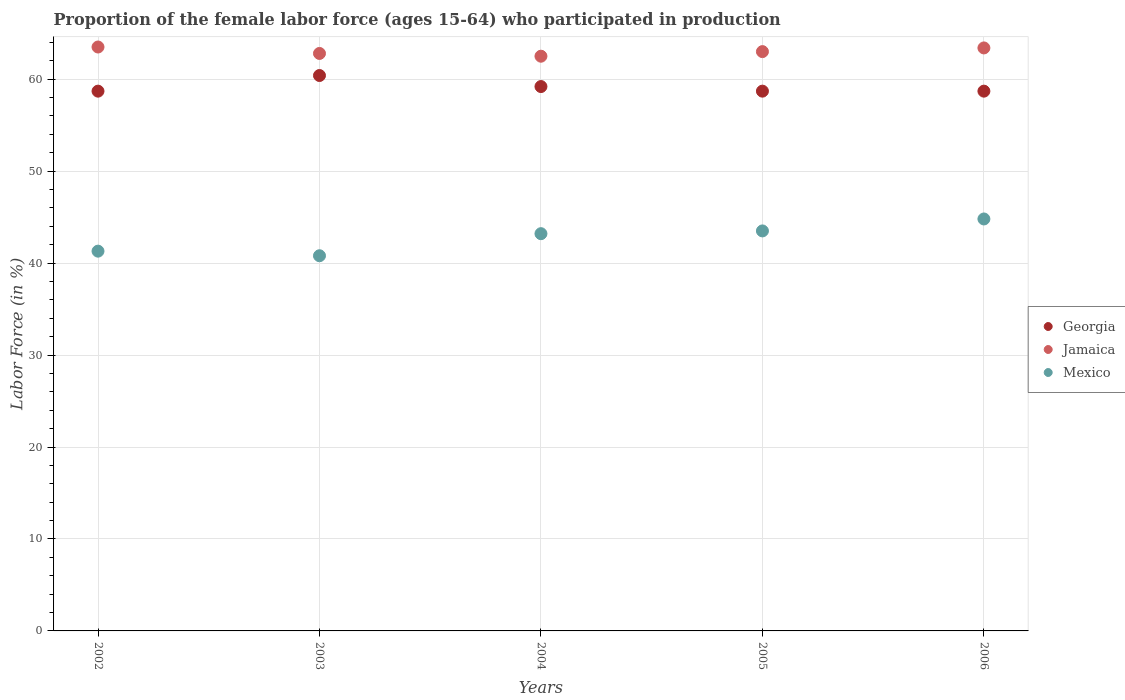What is the proportion of the female labor force who participated in production in Georgia in 2002?
Your response must be concise. 58.7. Across all years, what is the maximum proportion of the female labor force who participated in production in Jamaica?
Your response must be concise. 63.5. Across all years, what is the minimum proportion of the female labor force who participated in production in Georgia?
Make the answer very short. 58.7. In which year was the proportion of the female labor force who participated in production in Mexico maximum?
Make the answer very short. 2006. In which year was the proportion of the female labor force who participated in production in Jamaica minimum?
Offer a terse response. 2004. What is the total proportion of the female labor force who participated in production in Georgia in the graph?
Provide a succinct answer. 295.7. What is the difference between the proportion of the female labor force who participated in production in Mexico in 2003 and that in 2004?
Offer a very short reply. -2.4. What is the difference between the proportion of the female labor force who participated in production in Mexico in 2004 and the proportion of the female labor force who participated in production in Jamaica in 2002?
Provide a succinct answer. -20.3. What is the average proportion of the female labor force who participated in production in Mexico per year?
Make the answer very short. 42.72. In the year 2005, what is the difference between the proportion of the female labor force who participated in production in Georgia and proportion of the female labor force who participated in production in Jamaica?
Your response must be concise. -4.3. In how many years, is the proportion of the female labor force who participated in production in Jamaica greater than 54 %?
Provide a succinct answer. 5. What is the ratio of the proportion of the female labor force who participated in production in Mexico in 2003 to that in 2005?
Keep it short and to the point. 0.94. Is the proportion of the female labor force who participated in production in Georgia in 2004 less than that in 2006?
Offer a very short reply. No. Is the difference between the proportion of the female labor force who participated in production in Georgia in 2005 and 2006 greater than the difference between the proportion of the female labor force who participated in production in Jamaica in 2005 and 2006?
Keep it short and to the point. Yes. What is the difference between the highest and the second highest proportion of the female labor force who participated in production in Georgia?
Provide a succinct answer. 1.2. What is the difference between the highest and the lowest proportion of the female labor force who participated in production in Georgia?
Make the answer very short. 1.7. Does the proportion of the female labor force who participated in production in Georgia monotonically increase over the years?
Provide a short and direct response. No. Is the proportion of the female labor force who participated in production in Mexico strictly greater than the proportion of the female labor force who participated in production in Jamaica over the years?
Offer a very short reply. No. How many years are there in the graph?
Keep it short and to the point. 5. Are the values on the major ticks of Y-axis written in scientific E-notation?
Make the answer very short. No. Where does the legend appear in the graph?
Offer a terse response. Center right. How many legend labels are there?
Make the answer very short. 3. What is the title of the graph?
Your answer should be very brief. Proportion of the female labor force (ages 15-64) who participated in production. Does "Venezuela" appear as one of the legend labels in the graph?
Offer a terse response. No. What is the label or title of the X-axis?
Your response must be concise. Years. What is the label or title of the Y-axis?
Offer a very short reply. Labor Force (in %). What is the Labor Force (in %) in Georgia in 2002?
Ensure brevity in your answer.  58.7. What is the Labor Force (in %) in Jamaica in 2002?
Make the answer very short. 63.5. What is the Labor Force (in %) in Mexico in 2002?
Provide a succinct answer. 41.3. What is the Labor Force (in %) of Georgia in 2003?
Keep it short and to the point. 60.4. What is the Labor Force (in %) in Jamaica in 2003?
Offer a very short reply. 62.8. What is the Labor Force (in %) in Mexico in 2003?
Keep it short and to the point. 40.8. What is the Labor Force (in %) in Georgia in 2004?
Your answer should be compact. 59.2. What is the Labor Force (in %) of Jamaica in 2004?
Give a very brief answer. 62.5. What is the Labor Force (in %) in Mexico in 2004?
Offer a very short reply. 43.2. What is the Labor Force (in %) in Georgia in 2005?
Offer a very short reply. 58.7. What is the Labor Force (in %) in Jamaica in 2005?
Give a very brief answer. 63. What is the Labor Force (in %) of Mexico in 2005?
Provide a succinct answer. 43.5. What is the Labor Force (in %) in Georgia in 2006?
Keep it short and to the point. 58.7. What is the Labor Force (in %) in Jamaica in 2006?
Your answer should be compact. 63.4. What is the Labor Force (in %) in Mexico in 2006?
Your answer should be compact. 44.8. Across all years, what is the maximum Labor Force (in %) in Georgia?
Keep it short and to the point. 60.4. Across all years, what is the maximum Labor Force (in %) of Jamaica?
Ensure brevity in your answer.  63.5. Across all years, what is the maximum Labor Force (in %) in Mexico?
Give a very brief answer. 44.8. Across all years, what is the minimum Labor Force (in %) of Georgia?
Keep it short and to the point. 58.7. Across all years, what is the minimum Labor Force (in %) in Jamaica?
Make the answer very short. 62.5. Across all years, what is the minimum Labor Force (in %) in Mexico?
Make the answer very short. 40.8. What is the total Labor Force (in %) of Georgia in the graph?
Provide a short and direct response. 295.7. What is the total Labor Force (in %) of Jamaica in the graph?
Provide a short and direct response. 315.2. What is the total Labor Force (in %) of Mexico in the graph?
Give a very brief answer. 213.6. What is the difference between the Labor Force (in %) of Georgia in 2002 and that in 2003?
Your answer should be very brief. -1.7. What is the difference between the Labor Force (in %) in Jamaica in 2002 and that in 2003?
Your answer should be very brief. 0.7. What is the difference between the Labor Force (in %) of Mexico in 2002 and that in 2003?
Ensure brevity in your answer.  0.5. What is the difference between the Labor Force (in %) in Mexico in 2002 and that in 2004?
Your answer should be very brief. -1.9. What is the difference between the Labor Force (in %) of Georgia in 2002 and that in 2006?
Keep it short and to the point. 0. What is the difference between the Labor Force (in %) in Jamaica in 2002 and that in 2006?
Offer a terse response. 0.1. What is the difference between the Labor Force (in %) in Mexico in 2002 and that in 2006?
Offer a terse response. -3.5. What is the difference between the Labor Force (in %) of Mexico in 2003 and that in 2004?
Give a very brief answer. -2.4. What is the difference between the Labor Force (in %) in Georgia in 2003 and that in 2005?
Offer a terse response. 1.7. What is the difference between the Labor Force (in %) of Jamaica in 2003 and that in 2005?
Make the answer very short. -0.2. What is the difference between the Labor Force (in %) in Georgia in 2003 and that in 2006?
Offer a very short reply. 1.7. What is the difference between the Labor Force (in %) of Mexico in 2003 and that in 2006?
Make the answer very short. -4. What is the difference between the Labor Force (in %) in Mexico in 2004 and that in 2005?
Keep it short and to the point. -0.3. What is the difference between the Labor Force (in %) in Jamaica in 2004 and that in 2006?
Provide a short and direct response. -0.9. What is the difference between the Labor Force (in %) in Georgia in 2005 and that in 2006?
Provide a succinct answer. 0. What is the difference between the Labor Force (in %) in Mexico in 2005 and that in 2006?
Keep it short and to the point. -1.3. What is the difference between the Labor Force (in %) in Georgia in 2002 and the Labor Force (in %) in Mexico in 2003?
Your answer should be very brief. 17.9. What is the difference between the Labor Force (in %) of Jamaica in 2002 and the Labor Force (in %) of Mexico in 2003?
Give a very brief answer. 22.7. What is the difference between the Labor Force (in %) in Jamaica in 2002 and the Labor Force (in %) in Mexico in 2004?
Offer a very short reply. 20.3. What is the difference between the Labor Force (in %) of Jamaica in 2002 and the Labor Force (in %) of Mexico in 2005?
Offer a terse response. 20. What is the difference between the Labor Force (in %) of Jamaica in 2002 and the Labor Force (in %) of Mexico in 2006?
Your answer should be compact. 18.7. What is the difference between the Labor Force (in %) in Georgia in 2003 and the Labor Force (in %) in Jamaica in 2004?
Your answer should be very brief. -2.1. What is the difference between the Labor Force (in %) in Jamaica in 2003 and the Labor Force (in %) in Mexico in 2004?
Ensure brevity in your answer.  19.6. What is the difference between the Labor Force (in %) in Georgia in 2003 and the Labor Force (in %) in Mexico in 2005?
Your response must be concise. 16.9. What is the difference between the Labor Force (in %) of Jamaica in 2003 and the Labor Force (in %) of Mexico in 2005?
Provide a short and direct response. 19.3. What is the difference between the Labor Force (in %) of Georgia in 2003 and the Labor Force (in %) of Jamaica in 2006?
Your response must be concise. -3. What is the difference between the Labor Force (in %) of Jamaica in 2003 and the Labor Force (in %) of Mexico in 2006?
Make the answer very short. 18. What is the difference between the Labor Force (in %) of Georgia in 2005 and the Labor Force (in %) of Jamaica in 2006?
Provide a short and direct response. -4.7. What is the difference between the Labor Force (in %) in Georgia in 2005 and the Labor Force (in %) in Mexico in 2006?
Offer a very short reply. 13.9. What is the average Labor Force (in %) in Georgia per year?
Ensure brevity in your answer.  59.14. What is the average Labor Force (in %) of Jamaica per year?
Ensure brevity in your answer.  63.04. What is the average Labor Force (in %) of Mexico per year?
Keep it short and to the point. 42.72. In the year 2002, what is the difference between the Labor Force (in %) in Georgia and Labor Force (in %) in Jamaica?
Make the answer very short. -4.8. In the year 2003, what is the difference between the Labor Force (in %) in Georgia and Labor Force (in %) in Jamaica?
Provide a succinct answer. -2.4. In the year 2003, what is the difference between the Labor Force (in %) in Georgia and Labor Force (in %) in Mexico?
Your answer should be very brief. 19.6. In the year 2003, what is the difference between the Labor Force (in %) of Jamaica and Labor Force (in %) of Mexico?
Your response must be concise. 22. In the year 2004, what is the difference between the Labor Force (in %) of Georgia and Labor Force (in %) of Jamaica?
Offer a terse response. -3.3. In the year 2004, what is the difference between the Labor Force (in %) in Georgia and Labor Force (in %) in Mexico?
Ensure brevity in your answer.  16. In the year 2004, what is the difference between the Labor Force (in %) of Jamaica and Labor Force (in %) of Mexico?
Make the answer very short. 19.3. In the year 2005, what is the difference between the Labor Force (in %) in Georgia and Labor Force (in %) in Mexico?
Offer a terse response. 15.2. In the year 2005, what is the difference between the Labor Force (in %) of Jamaica and Labor Force (in %) of Mexico?
Offer a terse response. 19.5. In the year 2006, what is the difference between the Labor Force (in %) in Georgia and Labor Force (in %) in Jamaica?
Offer a terse response. -4.7. In the year 2006, what is the difference between the Labor Force (in %) in Georgia and Labor Force (in %) in Mexico?
Give a very brief answer. 13.9. In the year 2006, what is the difference between the Labor Force (in %) of Jamaica and Labor Force (in %) of Mexico?
Your answer should be very brief. 18.6. What is the ratio of the Labor Force (in %) of Georgia in 2002 to that in 2003?
Offer a very short reply. 0.97. What is the ratio of the Labor Force (in %) in Jamaica in 2002 to that in 2003?
Your response must be concise. 1.01. What is the ratio of the Labor Force (in %) of Mexico in 2002 to that in 2003?
Your answer should be compact. 1.01. What is the ratio of the Labor Force (in %) of Jamaica in 2002 to that in 2004?
Keep it short and to the point. 1.02. What is the ratio of the Labor Force (in %) in Mexico in 2002 to that in 2004?
Make the answer very short. 0.96. What is the ratio of the Labor Force (in %) in Georgia in 2002 to that in 2005?
Your answer should be compact. 1. What is the ratio of the Labor Force (in %) of Jamaica in 2002 to that in 2005?
Offer a terse response. 1.01. What is the ratio of the Labor Force (in %) in Mexico in 2002 to that in 2005?
Ensure brevity in your answer.  0.95. What is the ratio of the Labor Force (in %) of Mexico in 2002 to that in 2006?
Give a very brief answer. 0.92. What is the ratio of the Labor Force (in %) of Georgia in 2003 to that in 2004?
Provide a succinct answer. 1.02. What is the ratio of the Labor Force (in %) of Jamaica in 2003 to that in 2004?
Keep it short and to the point. 1. What is the ratio of the Labor Force (in %) of Georgia in 2003 to that in 2005?
Give a very brief answer. 1.03. What is the ratio of the Labor Force (in %) in Mexico in 2003 to that in 2005?
Your response must be concise. 0.94. What is the ratio of the Labor Force (in %) of Georgia in 2003 to that in 2006?
Your response must be concise. 1.03. What is the ratio of the Labor Force (in %) in Jamaica in 2003 to that in 2006?
Your answer should be compact. 0.99. What is the ratio of the Labor Force (in %) of Mexico in 2003 to that in 2006?
Keep it short and to the point. 0.91. What is the ratio of the Labor Force (in %) in Georgia in 2004 to that in 2005?
Provide a short and direct response. 1.01. What is the ratio of the Labor Force (in %) of Mexico in 2004 to that in 2005?
Provide a succinct answer. 0.99. What is the ratio of the Labor Force (in %) in Georgia in 2004 to that in 2006?
Ensure brevity in your answer.  1.01. What is the ratio of the Labor Force (in %) in Jamaica in 2004 to that in 2006?
Ensure brevity in your answer.  0.99. What is the ratio of the Labor Force (in %) of Georgia in 2005 to that in 2006?
Provide a succinct answer. 1. What is the ratio of the Labor Force (in %) of Mexico in 2005 to that in 2006?
Your response must be concise. 0.97. What is the difference between the highest and the second highest Labor Force (in %) of Georgia?
Your response must be concise. 1.2. What is the difference between the highest and the second highest Labor Force (in %) in Mexico?
Your answer should be compact. 1.3. What is the difference between the highest and the lowest Labor Force (in %) in Jamaica?
Your answer should be compact. 1. 